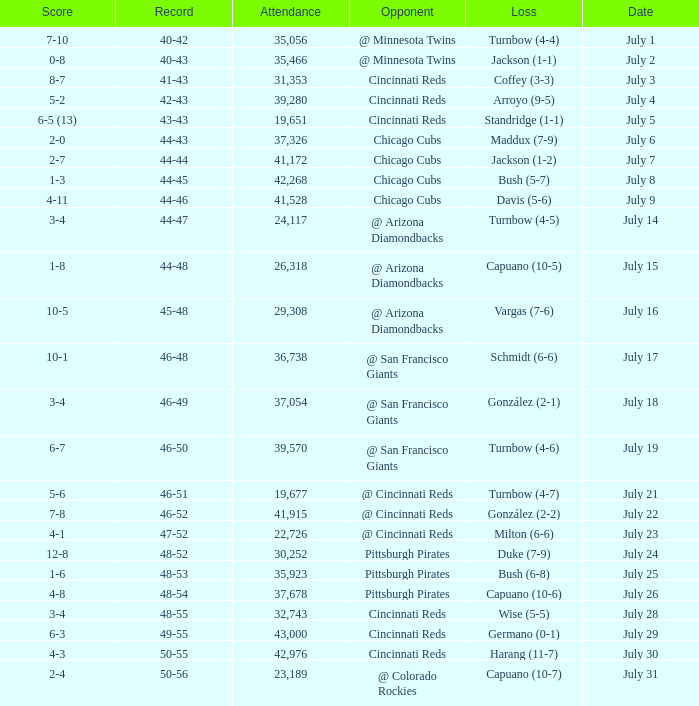What was the record at the game that had a score of 7-10? 40-42. 